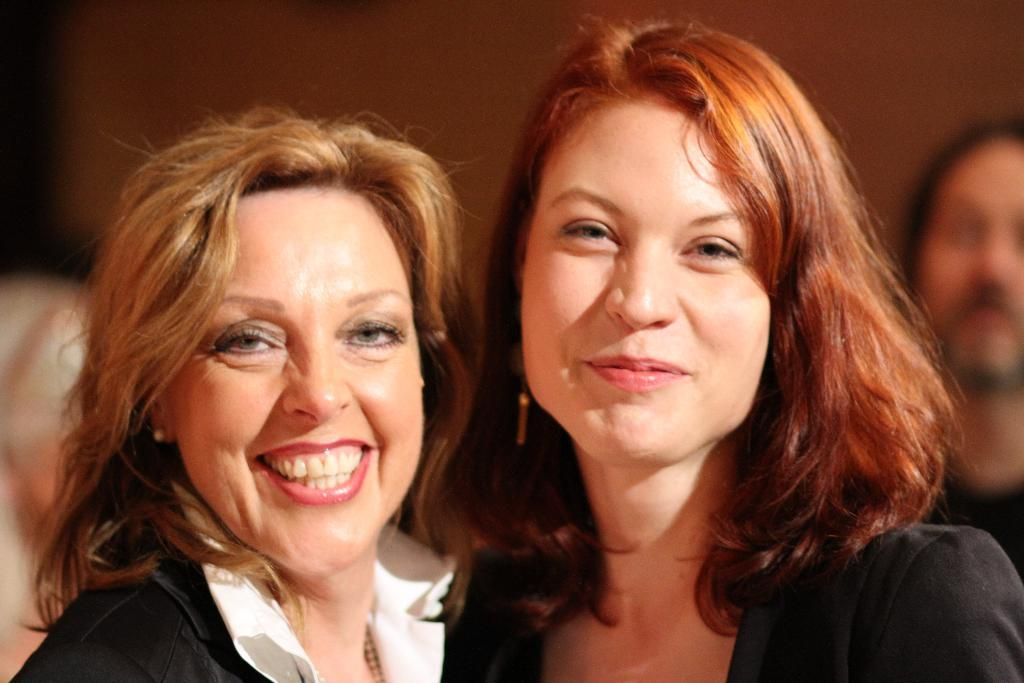How many women are in the image? There are two women in the image. What are the women wearing? The women are wearing black jackets. What can be seen in the background of the image? There is a group of people and a black wall in the background of the image. How many toes does the bike in the image have? There is no bike present in the image, so it is not possible to determine the number of toes on a bike. 